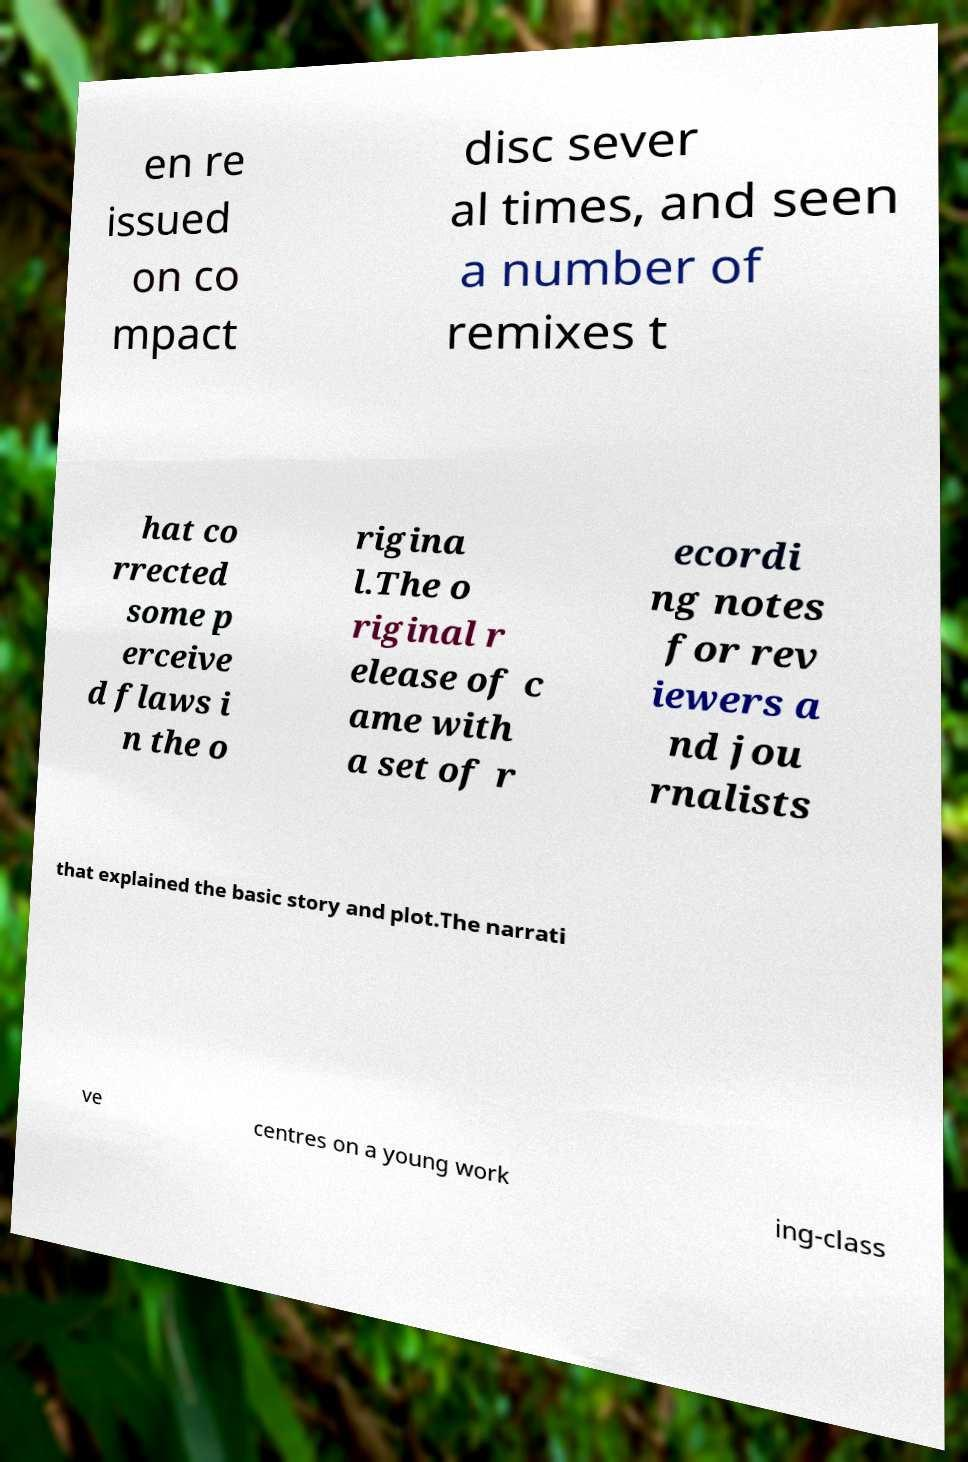There's text embedded in this image that I need extracted. Can you transcribe it verbatim? en re issued on co mpact disc sever al times, and seen a number of remixes t hat co rrected some p erceive d flaws i n the o rigina l.The o riginal r elease of c ame with a set of r ecordi ng notes for rev iewers a nd jou rnalists that explained the basic story and plot.The narrati ve centres on a young work ing-class 